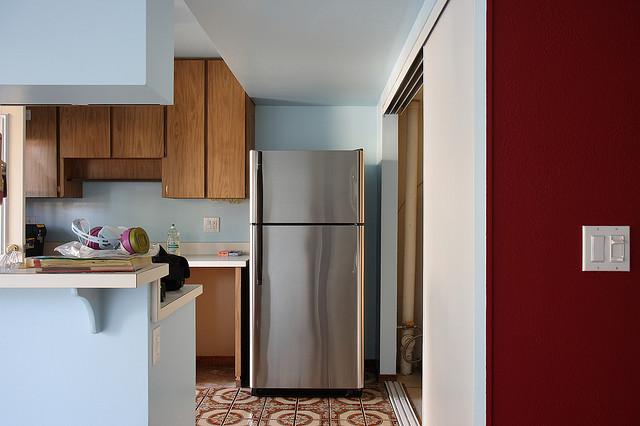What is the color of the carpet?
Keep it brief. Brown. Is there a carpet on the floor?
Be succinct. Yes. What color is the refrigerator?
Answer briefly. Silver. What is this device?
Quick response, please. Refrigerator. 